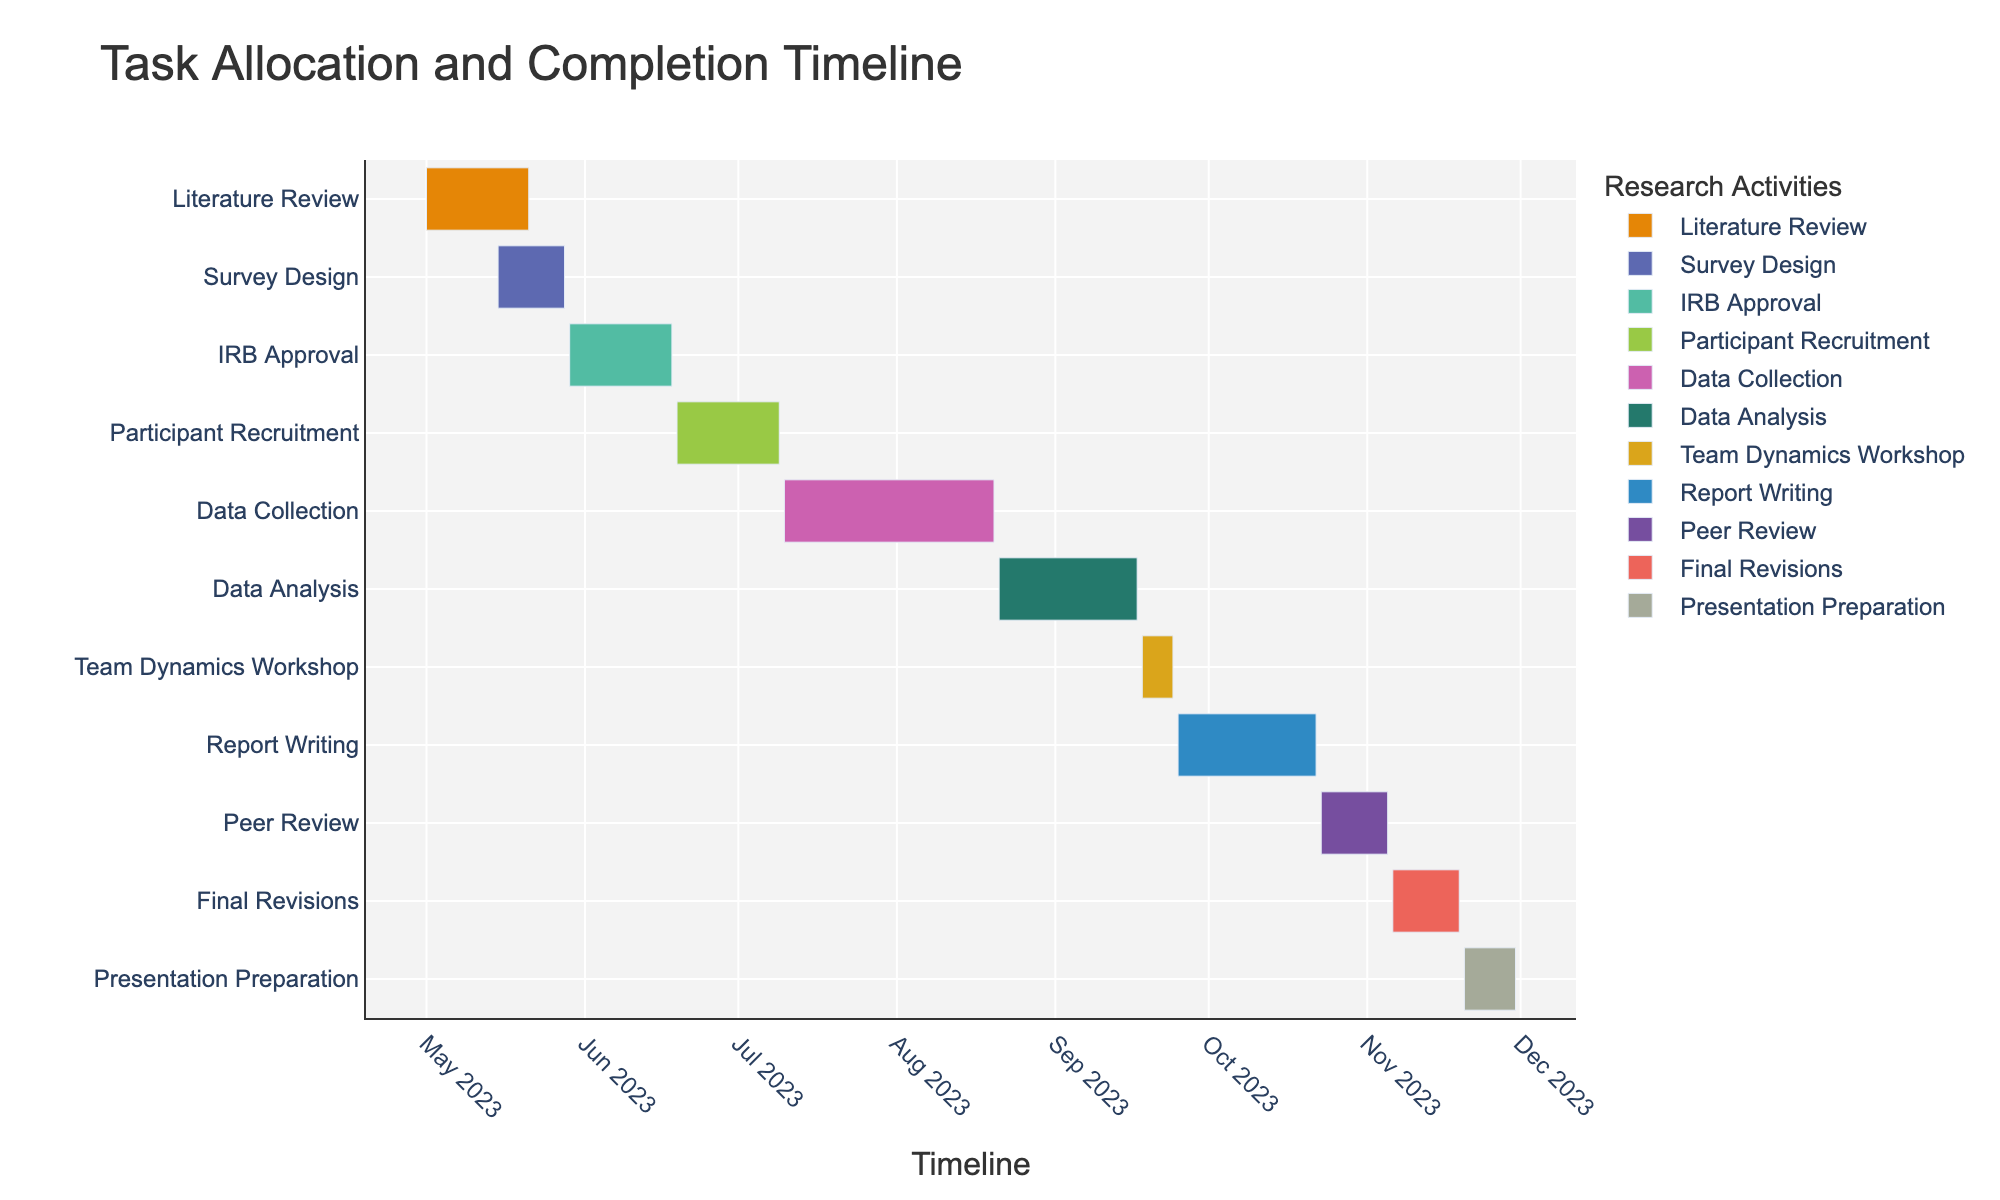What is the duration of the Literature Review task? The figure shows the duration of each task. For the Literature Review task, the duration is listed.
Answer: 21 days Which task has the shortest duration? By looking at the durations of all tasks in the figure, the shortest duration is for one specific task. The Team Dynamics Workshop has the shortest duration.
Answer: Team Dynamics Workshop What are the start and end dates for the Data Collection task? Refer to the start and end dates labels on the timeline for the Data Collection task in the figure. It starts on July 10, 2023, and ends on August 20, 2023.
Answer: July 10, 2023 - August 20, 2023 Which tasks overlap in time with the Survey Design task? Check the timeline positions of tasks. Survey Design overlaps with the Literature Review and IRB Approval tasks as their timelines intersect with its duration from May 15, 2023, to May 28, 2023.
Answer: Literature Review, IRB Approval How many days after the completion of Data Collection does Report Writing start? Data Collection ends on August 20, 2023, and Report Writing starts on September 25, 2023. Calculate the days between these dates, which is 36 days.
Answer: 36 days Which task ends first, Participant Recruitment or Data Collection? Check the end dates of both tasks in the figure. Participant Recruitment ends on July 9, 2023, while Data Collection ends on August 20, 2023.
Answer: Participant Recruitment What is the combined duration of the IRB Approval and Participant Recruitment tasks? Add the durations of these two tasks: IRB Approval (21 days) and Participant Recruitment (21 days), resulting in a total of 42 days.
Answer: 42 days Do the Report Writing and Peer Review tasks overlap? Check the timeline for the start and end dates of these tasks. Report Writing ends on October 22, 2023, and Peer Review starts on October 23, 2023, so there is no overlap as they are sequential.
Answer: No How long is the total timeline from the start of the first task to the end of the last task? Identify the start of the first task (Literature Review on May 1, 2023) and the end of the last task (Presentation Preparation on November 30, 2023). Calculate the total days between these dates.
Answer: 214 days Which tasks are ongoing simultaneously during the month of June 2023? Check the tasks' timelines during June 2023. The ongoing tasks are IRB Approval and Participant Recruitment.
Answer: IRB Approval, Participant Recruitment 